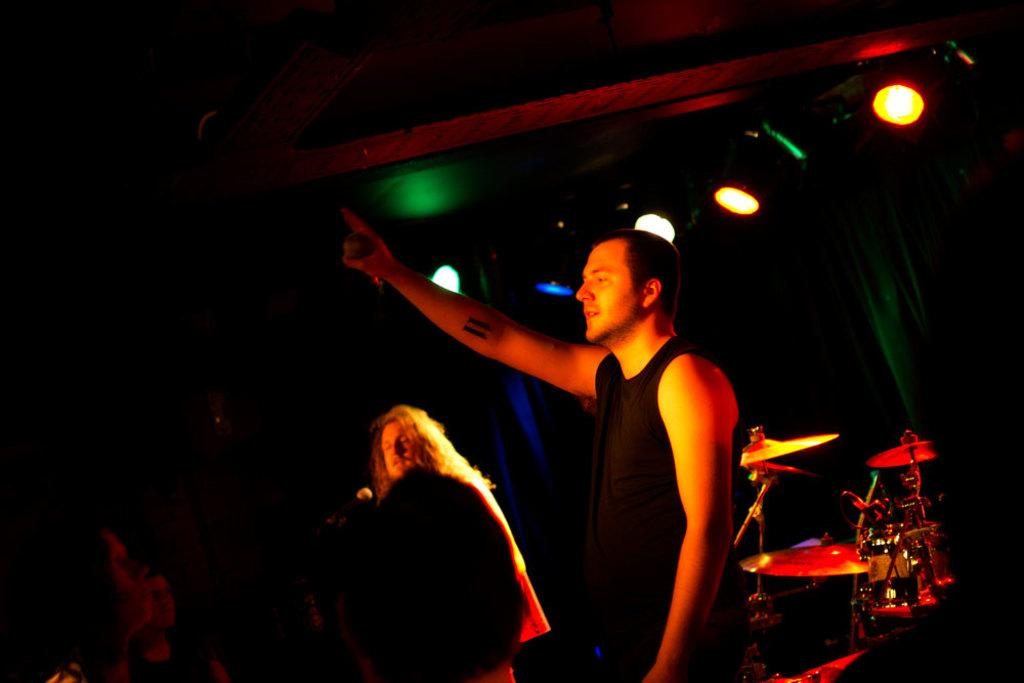What time of day is depicted in the image? The image is taken during night time. How many people are in the image? There are two persons in the image. What can be seen in the image besides the people? There are lights and musical instruments in the image. What type of neck accessory is the giraffe wearing in the image? There is no giraffe present in the image, so it is not possible to determine what type of neck accessory it might be wearing. 